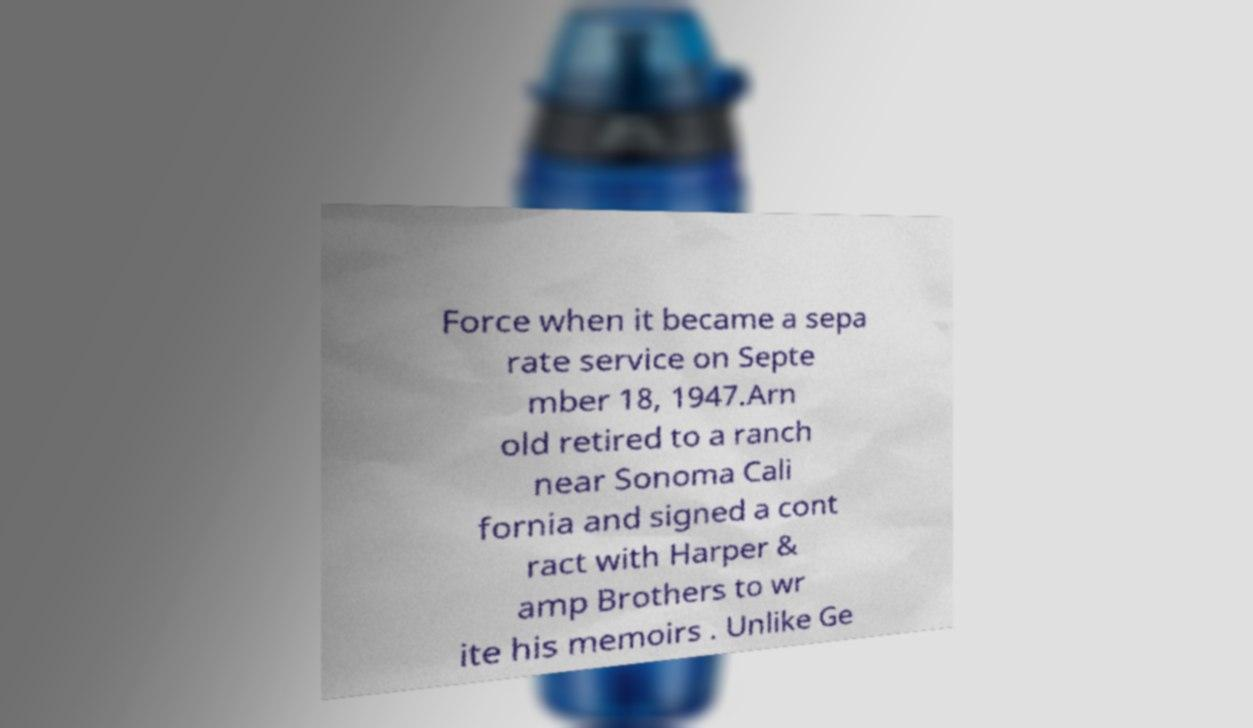There's text embedded in this image that I need extracted. Can you transcribe it verbatim? Force when it became a sepa rate service on Septe mber 18, 1947.Arn old retired to a ranch near Sonoma Cali fornia and signed a cont ract with Harper & amp Brothers to wr ite his memoirs . Unlike Ge 